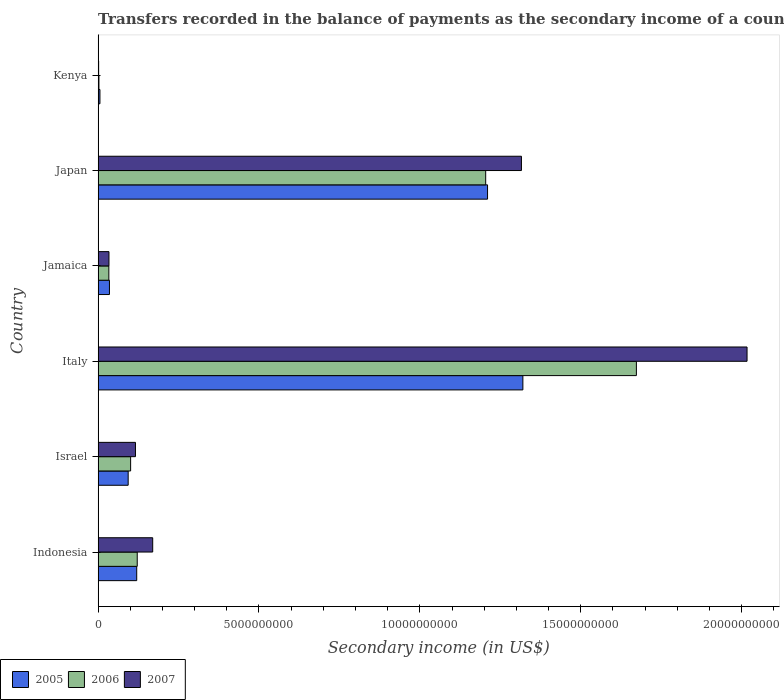Are the number of bars per tick equal to the number of legend labels?
Offer a very short reply. Yes. How many bars are there on the 4th tick from the top?
Offer a terse response. 3. How many bars are there on the 6th tick from the bottom?
Your answer should be very brief. 3. In how many cases, is the number of bars for a given country not equal to the number of legend labels?
Offer a very short reply. 0. What is the secondary income of in 2005 in Japan?
Ensure brevity in your answer.  1.21e+1. Across all countries, what is the maximum secondary income of in 2007?
Your response must be concise. 2.02e+1. Across all countries, what is the minimum secondary income of in 2005?
Your response must be concise. 5.64e+07. In which country was the secondary income of in 2007 minimum?
Keep it short and to the point. Kenya. What is the total secondary income of in 2005 in the graph?
Your answer should be compact. 2.78e+1. What is the difference between the secondary income of in 2007 in Indonesia and that in Italy?
Ensure brevity in your answer.  -1.85e+1. What is the difference between the secondary income of in 2007 in Japan and the secondary income of in 2005 in Jamaica?
Make the answer very short. 1.28e+1. What is the average secondary income of in 2005 per country?
Your answer should be very brief. 4.64e+09. What is the difference between the secondary income of in 2005 and secondary income of in 2007 in Italy?
Provide a short and direct response. -6.97e+09. In how many countries, is the secondary income of in 2007 greater than 9000000000 US$?
Ensure brevity in your answer.  2. What is the ratio of the secondary income of in 2005 in Israel to that in Italy?
Your response must be concise. 0.07. What is the difference between the highest and the second highest secondary income of in 2006?
Offer a terse response. 4.68e+09. What is the difference between the highest and the lowest secondary income of in 2006?
Offer a terse response. 1.67e+1. What does the 3rd bar from the top in Israel represents?
Ensure brevity in your answer.  2005. Is it the case that in every country, the sum of the secondary income of in 2006 and secondary income of in 2007 is greater than the secondary income of in 2005?
Give a very brief answer. No. How many countries are there in the graph?
Keep it short and to the point. 6. Does the graph contain any zero values?
Keep it short and to the point. No. Does the graph contain grids?
Ensure brevity in your answer.  No. What is the title of the graph?
Your answer should be very brief. Transfers recorded in the balance of payments as the secondary income of a country. Does "1968" appear as one of the legend labels in the graph?
Keep it short and to the point. No. What is the label or title of the X-axis?
Your answer should be very brief. Secondary income (in US$). What is the Secondary income (in US$) in 2005 in Indonesia?
Keep it short and to the point. 1.20e+09. What is the Secondary income (in US$) of 2006 in Indonesia?
Your answer should be compact. 1.22e+09. What is the Secondary income (in US$) of 2007 in Indonesia?
Give a very brief answer. 1.70e+09. What is the Secondary income (in US$) in 2005 in Israel?
Make the answer very short. 9.34e+08. What is the Secondary income (in US$) in 2006 in Israel?
Your answer should be compact. 1.01e+09. What is the Secondary income (in US$) in 2007 in Israel?
Offer a terse response. 1.16e+09. What is the Secondary income (in US$) of 2005 in Italy?
Your answer should be very brief. 1.32e+1. What is the Secondary income (in US$) in 2006 in Italy?
Provide a short and direct response. 1.67e+1. What is the Secondary income (in US$) of 2007 in Italy?
Provide a succinct answer. 2.02e+1. What is the Secondary income (in US$) in 2005 in Jamaica?
Provide a succinct answer. 3.52e+08. What is the Secondary income (in US$) of 2006 in Jamaica?
Your answer should be compact. 3.33e+08. What is the Secondary income (in US$) of 2007 in Jamaica?
Provide a short and direct response. 3.37e+08. What is the Secondary income (in US$) in 2005 in Japan?
Offer a terse response. 1.21e+1. What is the Secondary income (in US$) of 2006 in Japan?
Give a very brief answer. 1.20e+1. What is the Secondary income (in US$) of 2007 in Japan?
Provide a short and direct response. 1.32e+1. What is the Secondary income (in US$) of 2005 in Kenya?
Ensure brevity in your answer.  5.64e+07. What is the Secondary income (in US$) in 2006 in Kenya?
Your answer should be very brief. 2.54e+07. What is the Secondary income (in US$) in 2007 in Kenya?
Ensure brevity in your answer.  1.64e+07. Across all countries, what is the maximum Secondary income (in US$) of 2005?
Ensure brevity in your answer.  1.32e+1. Across all countries, what is the maximum Secondary income (in US$) in 2006?
Your response must be concise. 1.67e+1. Across all countries, what is the maximum Secondary income (in US$) in 2007?
Ensure brevity in your answer.  2.02e+1. Across all countries, what is the minimum Secondary income (in US$) of 2005?
Keep it short and to the point. 5.64e+07. Across all countries, what is the minimum Secondary income (in US$) of 2006?
Offer a terse response. 2.54e+07. Across all countries, what is the minimum Secondary income (in US$) in 2007?
Your answer should be very brief. 1.64e+07. What is the total Secondary income (in US$) in 2005 in the graph?
Your answer should be very brief. 2.78e+1. What is the total Secondary income (in US$) in 2006 in the graph?
Provide a succinct answer. 3.14e+1. What is the total Secondary income (in US$) of 2007 in the graph?
Provide a short and direct response. 3.65e+1. What is the difference between the Secondary income (in US$) of 2005 in Indonesia and that in Israel?
Offer a very short reply. 2.66e+08. What is the difference between the Secondary income (in US$) of 2006 in Indonesia and that in Israel?
Your response must be concise. 2.05e+08. What is the difference between the Secondary income (in US$) of 2007 in Indonesia and that in Israel?
Keep it short and to the point. 5.36e+08. What is the difference between the Secondary income (in US$) of 2005 in Indonesia and that in Italy?
Provide a succinct answer. -1.20e+1. What is the difference between the Secondary income (in US$) in 2006 in Indonesia and that in Italy?
Offer a terse response. -1.55e+1. What is the difference between the Secondary income (in US$) of 2007 in Indonesia and that in Italy?
Your answer should be very brief. -1.85e+1. What is the difference between the Secondary income (in US$) in 2005 in Indonesia and that in Jamaica?
Your response must be concise. 8.47e+08. What is the difference between the Secondary income (in US$) of 2006 in Indonesia and that in Jamaica?
Provide a succinct answer. 8.83e+08. What is the difference between the Secondary income (in US$) in 2007 in Indonesia and that in Jamaica?
Your answer should be compact. 1.36e+09. What is the difference between the Secondary income (in US$) in 2005 in Indonesia and that in Japan?
Provide a short and direct response. -1.09e+1. What is the difference between the Secondary income (in US$) of 2006 in Indonesia and that in Japan?
Your answer should be compact. -1.08e+1. What is the difference between the Secondary income (in US$) of 2007 in Indonesia and that in Japan?
Provide a short and direct response. -1.15e+1. What is the difference between the Secondary income (in US$) of 2005 in Indonesia and that in Kenya?
Offer a very short reply. 1.14e+09. What is the difference between the Secondary income (in US$) in 2006 in Indonesia and that in Kenya?
Make the answer very short. 1.19e+09. What is the difference between the Secondary income (in US$) in 2007 in Indonesia and that in Kenya?
Your response must be concise. 1.68e+09. What is the difference between the Secondary income (in US$) in 2005 in Israel and that in Italy?
Ensure brevity in your answer.  -1.23e+1. What is the difference between the Secondary income (in US$) in 2006 in Israel and that in Italy?
Keep it short and to the point. -1.57e+1. What is the difference between the Secondary income (in US$) in 2007 in Israel and that in Italy?
Provide a short and direct response. -1.90e+1. What is the difference between the Secondary income (in US$) in 2005 in Israel and that in Jamaica?
Ensure brevity in your answer.  5.82e+08. What is the difference between the Secondary income (in US$) in 2006 in Israel and that in Jamaica?
Your answer should be very brief. 6.77e+08. What is the difference between the Secondary income (in US$) in 2007 in Israel and that in Jamaica?
Provide a short and direct response. 8.24e+08. What is the difference between the Secondary income (in US$) in 2005 in Israel and that in Japan?
Make the answer very short. -1.12e+1. What is the difference between the Secondary income (in US$) in 2006 in Israel and that in Japan?
Your answer should be compact. -1.10e+1. What is the difference between the Secondary income (in US$) of 2007 in Israel and that in Japan?
Make the answer very short. -1.20e+1. What is the difference between the Secondary income (in US$) of 2005 in Israel and that in Kenya?
Provide a short and direct response. 8.78e+08. What is the difference between the Secondary income (in US$) in 2006 in Israel and that in Kenya?
Your response must be concise. 9.85e+08. What is the difference between the Secondary income (in US$) in 2007 in Israel and that in Kenya?
Keep it short and to the point. 1.14e+09. What is the difference between the Secondary income (in US$) in 2005 in Italy and that in Jamaica?
Keep it short and to the point. 1.28e+1. What is the difference between the Secondary income (in US$) of 2006 in Italy and that in Jamaica?
Offer a terse response. 1.64e+1. What is the difference between the Secondary income (in US$) of 2007 in Italy and that in Jamaica?
Offer a terse response. 1.98e+1. What is the difference between the Secondary income (in US$) in 2005 in Italy and that in Japan?
Your response must be concise. 1.10e+09. What is the difference between the Secondary income (in US$) of 2006 in Italy and that in Japan?
Your answer should be very brief. 4.68e+09. What is the difference between the Secondary income (in US$) of 2007 in Italy and that in Japan?
Offer a very short reply. 7.01e+09. What is the difference between the Secondary income (in US$) of 2005 in Italy and that in Kenya?
Give a very brief answer. 1.31e+1. What is the difference between the Secondary income (in US$) in 2006 in Italy and that in Kenya?
Your answer should be compact. 1.67e+1. What is the difference between the Secondary income (in US$) of 2007 in Italy and that in Kenya?
Give a very brief answer. 2.02e+1. What is the difference between the Secondary income (in US$) of 2005 in Jamaica and that in Japan?
Your response must be concise. -1.18e+1. What is the difference between the Secondary income (in US$) of 2006 in Jamaica and that in Japan?
Your answer should be compact. -1.17e+1. What is the difference between the Secondary income (in US$) of 2007 in Jamaica and that in Japan?
Offer a terse response. -1.28e+1. What is the difference between the Secondary income (in US$) of 2005 in Jamaica and that in Kenya?
Give a very brief answer. 2.96e+08. What is the difference between the Secondary income (in US$) of 2006 in Jamaica and that in Kenya?
Offer a terse response. 3.08e+08. What is the difference between the Secondary income (in US$) of 2007 in Jamaica and that in Kenya?
Keep it short and to the point. 3.21e+08. What is the difference between the Secondary income (in US$) in 2005 in Japan and that in Kenya?
Make the answer very short. 1.20e+1. What is the difference between the Secondary income (in US$) in 2006 in Japan and that in Kenya?
Keep it short and to the point. 1.20e+1. What is the difference between the Secondary income (in US$) of 2007 in Japan and that in Kenya?
Give a very brief answer. 1.31e+1. What is the difference between the Secondary income (in US$) in 2005 in Indonesia and the Secondary income (in US$) in 2006 in Israel?
Your response must be concise. 1.89e+08. What is the difference between the Secondary income (in US$) in 2005 in Indonesia and the Secondary income (in US$) in 2007 in Israel?
Provide a short and direct response. 3.86e+07. What is the difference between the Secondary income (in US$) of 2006 in Indonesia and the Secondary income (in US$) of 2007 in Israel?
Provide a succinct answer. 5.47e+07. What is the difference between the Secondary income (in US$) of 2005 in Indonesia and the Secondary income (in US$) of 2006 in Italy?
Make the answer very short. -1.55e+1. What is the difference between the Secondary income (in US$) in 2005 in Indonesia and the Secondary income (in US$) in 2007 in Italy?
Your answer should be compact. -1.90e+1. What is the difference between the Secondary income (in US$) of 2006 in Indonesia and the Secondary income (in US$) of 2007 in Italy?
Your answer should be compact. -1.90e+1. What is the difference between the Secondary income (in US$) of 2005 in Indonesia and the Secondary income (in US$) of 2006 in Jamaica?
Provide a short and direct response. 8.66e+08. What is the difference between the Secondary income (in US$) of 2005 in Indonesia and the Secondary income (in US$) of 2007 in Jamaica?
Your answer should be very brief. 8.62e+08. What is the difference between the Secondary income (in US$) of 2006 in Indonesia and the Secondary income (in US$) of 2007 in Jamaica?
Offer a terse response. 8.78e+08. What is the difference between the Secondary income (in US$) in 2005 in Indonesia and the Secondary income (in US$) in 2006 in Japan?
Provide a short and direct response. -1.08e+1. What is the difference between the Secondary income (in US$) of 2005 in Indonesia and the Secondary income (in US$) of 2007 in Japan?
Your answer should be very brief. -1.20e+1. What is the difference between the Secondary income (in US$) in 2006 in Indonesia and the Secondary income (in US$) in 2007 in Japan?
Your answer should be compact. -1.19e+1. What is the difference between the Secondary income (in US$) in 2005 in Indonesia and the Secondary income (in US$) in 2006 in Kenya?
Keep it short and to the point. 1.17e+09. What is the difference between the Secondary income (in US$) in 2005 in Indonesia and the Secondary income (in US$) in 2007 in Kenya?
Provide a short and direct response. 1.18e+09. What is the difference between the Secondary income (in US$) in 2006 in Indonesia and the Secondary income (in US$) in 2007 in Kenya?
Provide a short and direct response. 1.20e+09. What is the difference between the Secondary income (in US$) of 2005 in Israel and the Secondary income (in US$) of 2006 in Italy?
Provide a short and direct response. -1.58e+1. What is the difference between the Secondary income (in US$) in 2005 in Israel and the Secondary income (in US$) in 2007 in Italy?
Provide a short and direct response. -1.92e+1. What is the difference between the Secondary income (in US$) in 2006 in Israel and the Secondary income (in US$) in 2007 in Italy?
Provide a short and direct response. -1.92e+1. What is the difference between the Secondary income (in US$) in 2005 in Israel and the Secondary income (in US$) in 2006 in Jamaica?
Provide a succinct answer. 6.01e+08. What is the difference between the Secondary income (in US$) in 2005 in Israel and the Secondary income (in US$) in 2007 in Jamaica?
Your answer should be very brief. 5.97e+08. What is the difference between the Secondary income (in US$) in 2006 in Israel and the Secondary income (in US$) in 2007 in Jamaica?
Keep it short and to the point. 6.73e+08. What is the difference between the Secondary income (in US$) in 2005 in Israel and the Secondary income (in US$) in 2006 in Japan?
Make the answer very short. -1.11e+1. What is the difference between the Secondary income (in US$) of 2005 in Israel and the Secondary income (in US$) of 2007 in Japan?
Provide a succinct answer. -1.22e+1. What is the difference between the Secondary income (in US$) in 2006 in Israel and the Secondary income (in US$) in 2007 in Japan?
Provide a short and direct response. -1.21e+1. What is the difference between the Secondary income (in US$) of 2005 in Israel and the Secondary income (in US$) of 2006 in Kenya?
Provide a succinct answer. 9.09e+08. What is the difference between the Secondary income (in US$) of 2005 in Israel and the Secondary income (in US$) of 2007 in Kenya?
Offer a very short reply. 9.18e+08. What is the difference between the Secondary income (in US$) in 2006 in Israel and the Secondary income (in US$) in 2007 in Kenya?
Give a very brief answer. 9.94e+08. What is the difference between the Secondary income (in US$) in 2005 in Italy and the Secondary income (in US$) in 2006 in Jamaica?
Give a very brief answer. 1.29e+1. What is the difference between the Secondary income (in US$) of 2005 in Italy and the Secondary income (in US$) of 2007 in Jamaica?
Provide a succinct answer. 1.29e+1. What is the difference between the Secondary income (in US$) in 2006 in Italy and the Secondary income (in US$) in 2007 in Jamaica?
Your answer should be compact. 1.64e+1. What is the difference between the Secondary income (in US$) in 2005 in Italy and the Secondary income (in US$) in 2006 in Japan?
Your answer should be compact. 1.16e+09. What is the difference between the Secondary income (in US$) of 2005 in Italy and the Secondary income (in US$) of 2007 in Japan?
Provide a short and direct response. 4.48e+07. What is the difference between the Secondary income (in US$) in 2006 in Italy and the Secondary income (in US$) in 2007 in Japan?
Offer a terse response. 3.57e+09. What is the difference between the Secondary income (in US$) in 2005 in Italy and the Secondary income (in US$) in 2006 in Kenya?
Your answer should be compact. 1.32e+1. What is the difference between the Secondary income (in US$) in 2005 in Italy and the Secondary income (in US$) in 2007 in Kenya?
Offer a terse response. 1.32e+1. What is the difference between the Secondary income (in US$) of 2006 in Italy and the Secondary income (in US$) of 2007 in Kenya?
Provide a short and direct response. 1.67e+1. What is the difference between the Secondary income (in US$) in 2005 in Jamaica and the Secondary income (in US$) in 2006 in Japan?
Your answer should be compact. -1.17e+1. What is the difference between the Secondary income (in US$) of 2005 in Jamaica and the Secondary income (in US$) of 2007 in Japan?
Offer a terse response. -1.28e+1. What is the difference between the Secondary income (in US$) in 2006 in Jamaica and the Secondary income (in US$) in 2007 in Japan?
Provide a short and direct response. -1.28e+1. What is the difference between the Secondary income (in US$) in 2005 in Jamaica and the Secondary income (in US$) in 2006 in Kenya?
Offer a very short reply. 3.27e+08. What is the difference between the Secondary income (in US$) of 2005 in Jamaica and the Secondary income (in US$) of 2007 in Kenya?
Provide a short and direct response. 3.36e+08. What is the difference between the Secondary income (in US$) of 2006 in Jamaica and the Secondary income (in US$) of 2007 in Kenya?
Provide a succinct answer. 3.17e+08. What is the difference between the Secondary income (in US$) in 2005 in Japan and the Secondary income (in US$) in 2006 in Kenya?
Your answer should be compact. 1.21e+1. What is the difference between the Secondary income (in US$) in 2005 in Japan and the Secondary income (in US$) in 2007 in Kenya?
Make the answer very short. 1.21e+1. What is the difference between the Secondary income (in US$) in 2006 in Japan and the Secondary income (in US$) in 2007 in Kenya?
Provide a succinct answer. 1.20e+1. What is the average Secondary income (in US$) in 2005 per country?
Your response must be concise. 4.64e+09. What is the average Secondary income (in US$) in 2006 per country?
Make the answer very short. 5.23e+09. What is the average Secondary income (in US$) of 2007 per country?
Make the answer very short. 6.09e+09. What is the difference between the Secondary income (in US$) of 2005 and Secondary income (in US$) of 2006 in Indonesia?
Offer a terse response. -1.61e+07. What is the difference between the Secondary income (in US$) of 2005 and Secondary income (in US$) of 2007 in Indonesia?
Offer a very short reply. -4.97e+08. What is the difference between the Secondary income (in US$) of 2006 and Secondary income (in US$) of 2007 in Indonesia?
Your answer should be compact. -4.81e+08. What is the difference between the Secondary income (in US$) in 2005 and Secondary income (in US$) in 2006 in Israel?
Offer a terse response. -7.63e+07. What is the difference between the Secondary income (in US$) in 2005 and Secondary income (in US$) in 2007 in Israel?
Give a very brief answer. -2.27e+08. What is the difference between the Secondary income (in US$) in 2006 and Secondary income (in US$) in 2007 in Israel?
Offer a very short reply. -1.51e+08. What is the difference between the Secondary income (in US$) of 2005 and Secondary income (in US$) of 2006 in Italy?
Provide a short and direct response. -3.53e+09. What is the difference between the Secondary income (in US$) of 2005 and Secondary income (in US$) of 2007 in Italy?
Offer a terse response. -6.97e+09. What is the difference between the Secondary income (in US$) in 2006 and Secondary income (in US$) in 2007 in Italy?
Keep it short and to the point. -3.44e+09. What is the difference between the Secondary income (in US$) in 2005 and Secondary income (in US$) in 2006 in Jamaica?
Give a very brief answer. 1.90e+07. What is the difference between the Secondary income (in US$) in 2005 and Secondary income (in US$) in 2007 in Jamaica?
Provide a short and direct response. 1.47e+07. What is the difference between the Secondary income (in US$) of 2006 and Secondary income (in US$) of 2007 in Jamaica?
Your response must be concise. -4.31e+06. What is the difference between the Secondary income (in US$) in 2005 and Secondary income (in US$) in 2006 in Japan?
Keep it short and to the point. 5.76e+07. What is the difference between the Secondary income (in US$) in 2005 and Secondary income (in US$) in 2007 in Japan?
Provide a short and direct response. -1.05e+09. What is the difference between the Secondary income (in US$) of 2006 and Secondary income (in US$) of 2007 in Japan?
Your answer should be very brief. -1.11e+09. What is the difference between the Secondary income (in US$) of 2005 and Secondary income (in US$) of 2006 in Kenya?
Your answer should be compact. 3.10e+07. What is the difference between the Secondary income (in US$) in 2005 and Secondary income (in US$) in 2007 in Kenya?
Make the answer very short. 4.00e+07. What is the difference between the Secondary income (in US$) in 2006 and Secondary income (in US$) in 2007 in Kenya?
Your response must be concise. 9.03e+06. What is the ratio of the Secondary income (in US$) in 2005 in Indonesia to that in Israel?
Offer a very short reply. 1.28. What is the ratio of the Secondary income (in US$) in 2006 in Indonesia to that in Israel?
Provide a short and direct response. 1.2. What is the ratio of the Secondary income (in US$) of 2007 in Indonesia to that in Israel?
Your answer should be very brief. 1.46. What is the ratio of the Secondary income (in US$) of 2005 in Indonesia to that in Italy?
Provide a short and direct response. 0.09. What is the ratio of the Secondary income (in US$) in 2006 in Indonesia to that in Italy?
Keep it short and to the point. 0.07. What is the ratio of the Secondary income (in US$) of 2007 in Indonesia to that in Italy?
Give a very brief answer. 0.08. What is the ratio of the Secondary income (in US$) in 2005 in Indonesia to that in Jamaica?
Give a very brief answer. 3.41. What is the ratio of the Secondary income (in US$) in 2006 in Indonesia to that in Jamaica?
Give a very brief answer. 3.65. What is the ratio of the Secondary income (in US$) in 2007 in Indonesia to that in Jamaica?
Ensure brevity in your answer.  5.03. What is the ratio of the Secondary income (in US$) in 2005 in Indonesia to that in Japan?
Your response must be concise. 0.1. What is the ratio of the Secondary income (in US$) of 2006 in Indonesia to that in Japan?
Give a very brief answer. 0.1. What is the ratio of the Secondary income (in US$) of 2007 in Indonesia to that in Japan?
Give a very brief answer. 0.13. What is the ratio of the Secondary income (in US$) of 2005 in Indonesia to that in Kenya?
Ensure brevity in your answer.  21.27. What is the ratio of the Secondary income (in US$) of 2006 in Indonesia to that in Kenya?
Offer a terse response. 47.87. What is the ratio of the Secondary income (in US$) in 2007 in Indonesia to that in Kenya?
Provide a succinct answer. 103.67. What is the ratio of the Secondary income (in US$) in 2005 in Israel to that in Italy?
Offer a very short reply. 0.07. What is the ratio of the Secondary income (in US$) in 2006 in Israel to that in Italy?
Provide a short and direct response. 0.06. What is the ratio of the Secondary income (in US$) of 2007 in Israel to that in Italy?
Your answer should be compact. 0.06. What is the ratio of the Secondary income (in US$) in 2005 in Israel to that in Jamaica?
Keep it short and to the point. 2.65. What is the ratio of the Secondary income (in US$) of 2006 in Israel to that in Jamaica?
Ensure brevity in your answer.  3.03. What is the ratio of the Secondary income (in US$) in 2007 in Israel to that in Jamaica?
Your response must be concise. 3.44. What is the ratio of the Secondary income (in US$) in 2005 in Israel to that in Japan?
Your response must be concise. 0.08. What is the ratio of the Secondary income (in US$) in 2006 in Israel to that in Japan?
Your answer should be very brief. 0.08. What is the ratio of the Secondary income (in US$) in 2007 in Israel to that in Japan?
Offer a terse response. 0.09. What is the ratio of the Secondary income (in US$) of 2005 in Israel to that in Kenya?
Offer a terse response. 16.56. What is the ratio of the Secondary income (in US$) in 2006 in Israel to that in Kenya?
Your answer should be compact. 39.78. What is the ratio of the Secondary income (in US$) of 2007 in Israel to that in Kenya?
Provide a succinct answer. 70.95. What is the ratio of the Secondary income (in US$) of 2005 in Italy to that in Jamaica?
Offer a terse response. 37.48. What is the ratio of the Secondary income (in US$) in 2006 in Italy to that in Jamaica?
Give a very brief answer. 50.21. What is the ratio of the Secondary income (in US$) of 2007 in Italy to that in Jamaica?
Offer a very short reply. 59.76. What is the ratio of the Secondary income (in US$) in 2005 in Italy to that in Japan?
Offer a very short reply. 1.09. What is the ratio of the Secondary income (in US$) of 2006 in Italy to that in Japan?
Provide a succinct answer. 1.39. What is the ratio of the Secondary income (in US$) in 2007 in Italy to that in Japan?
Ensure brevity in your answer.  1.53. What is the ratio of the Secondary income (in US$) of 2005 in Italy to that in Kenya?
Give a very brief answer. 234.04. What is the ratio of the Secondary income (in US$) of 2006 in Italy to that in Kenya?
Keep it short and to the point. 658.68. What is the ratio of the Secondary income (in US$) of 2007 in Italy to that in Kenya?
Ensure brevity in your answer.  1232.49. What is the ratio of the Secondary income (in US$) of 2005 in Jamaica to that in Japan?
Your answer should be very brief. 0.03. What is the ratio of the Secondary income (in US$) in 2006 in Jamaica to that in Japan?
Your response must be concise. 0.03. What is the ratio of the Secondary income (in US$) of 2007 in Jamaica to that in Japan?
Provide a short and direct response. 0.03. What is the ratio of the Secondary income (in US$) in 2005 in Jamaica to that in Kenya?
Offer a terse response. 6.24. What is the ratio of the Secondary income (in US$) of 2006 in Jamaica to that in Kenya?
Offer a very short reply. 13.12. What is the ratio of the Secondary income (in US$) in 2007 in Jamaica to that in Kenya?
Keep it short and to the point. 20.62. What is the ratio of the Secondary income (in US$) of 2005 in Japan to that in Kenya?
Keep it short and to the point. 214.57. What is the ratio of the Secondary income (in US$) of 2006 in Japan to that in Kenya?
Offer a very short reply. 474.27. What is the ratio of the Secondary income (in US$) of 2007 in Japan to that in Kenya?
Make the answer very short. 804. What is the difference between the highest and the second highest Secondary income (in US$) of 2005?
Provide a short and direct response. 1.10e+09. What is the difference between the highest and the second highest Secondary income (in US$) of 2006?
Your answer should be very brief. 4.68e+09. What is the difference between the highest and the second highest Secondary income (in US$) in 2007?
Make the answer very short. 7.01e+09. What is the difference between the highest and the lowest Secondary income (in US$) in 2005?
Provide a short and direct response. 1.31e+1. What is the difference between the highest and the lowest Secondary income (in US$) of 2006?
Give a very brief answer. 1.67e+1. What is the difference between the highest and the lowest Secondary income (in US$) in 2007?
Give a very brief answer. 2.02e+1. 